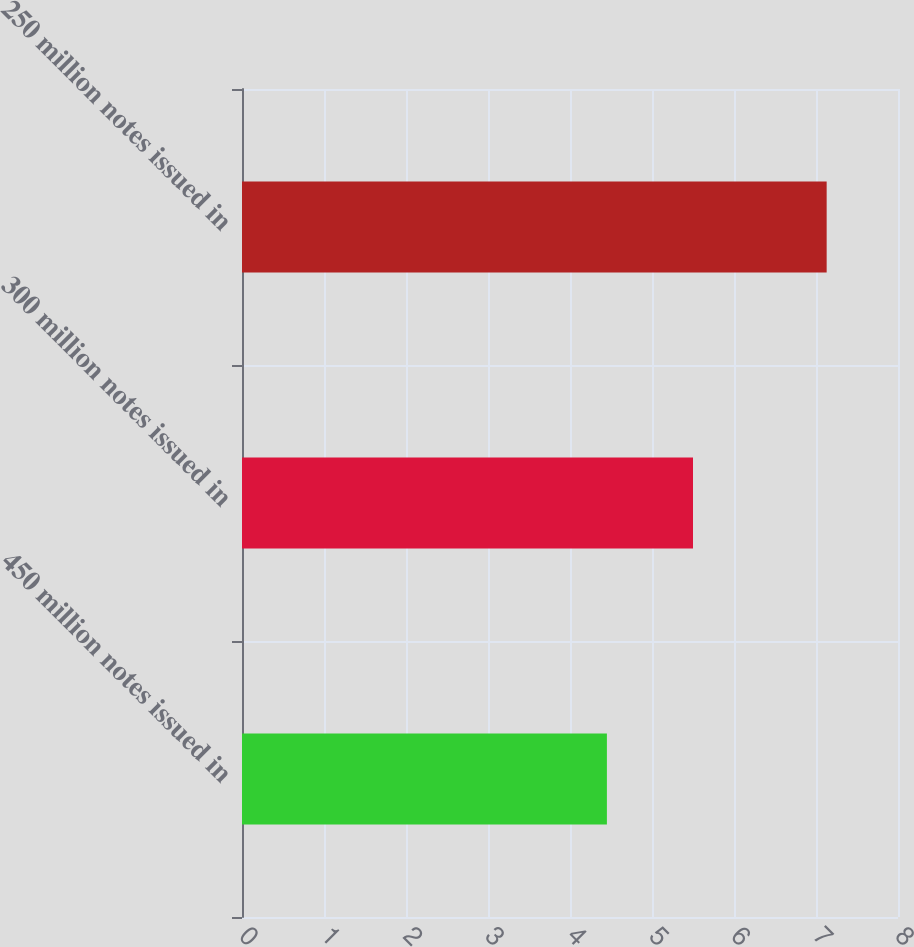Convert chart to OTSL. <chart><loc_0><loc_0><loc_500><loc_500><bar_chart><fcel>450 million notes issued in<fcel>300 million notes issued in<fcel>250 million notes issued in<nl><fcel>4.45<fcel>5.5<fcel>7.13<nl></chart> 